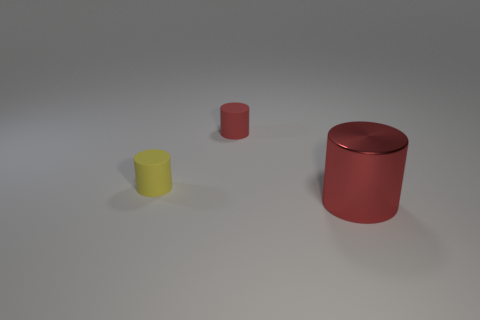Is there any other thing that is the same material as the big cylinder?
Your answer should be very brief. No. How many matte things are yellow things or cylinders?
Your answer should be compact. 2. Is the red object that is behind the red metal cylinder made of the same material as the red cylinder in front of the tiny yellow cylinder?
Make the answer very short. No. Are any spheres visible?
Make the answer very short. No. There is a red object that is left of the large red metallic cylinder; does it have the same shape as the rubber thing in front of the red rubber cylinder?
Ensure brevity in your answer.  Yes. Are there any yellow cylinders made of the same material as the large object?
Your response must be concise. No. Is the tiny cylinder that is behind the tiny yellow rubber cylinder made of the same material as the large red object?
Your answer should be very brief. No. Is the number of things on the left side of the big red shiny thing greater than the number of yellow cylinders that are in front of the tiny red rubber cylinder?
Give a very brief answer. Yes. The other object that is the same size as the yellow thing is what color?
Your answer should be compact. Red. Is there a thing of the same color as the metallic cylinder?
Your answer should be compact. Yes. 